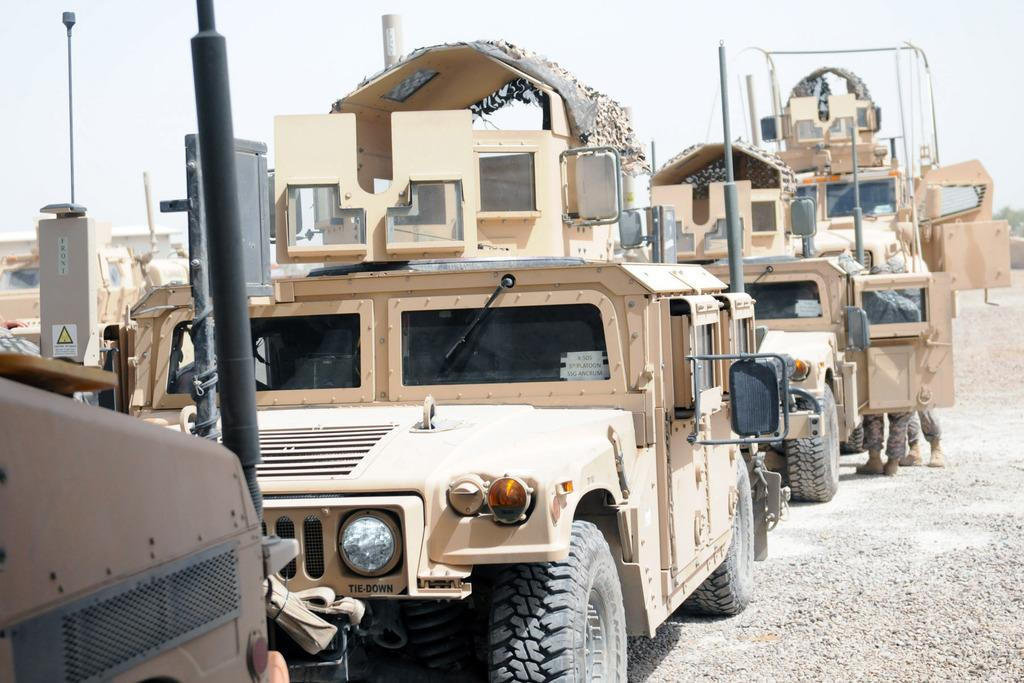What types of objects are present in the image? There are vehicles and persons in the image. Can you describe the natural elements in the image? There are leaves on the right side of the image, and the sky is cloudy. What type of chess piece is visible on the left side of the image? There is no chess piece present in the image. What is the sack used for in the image? There is no sack present in the image. 